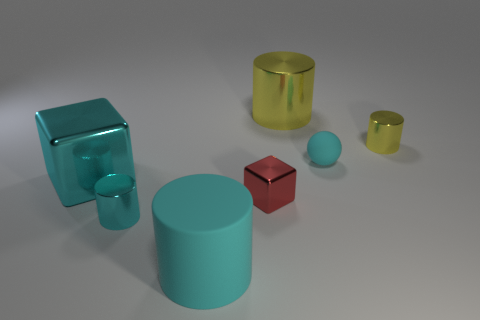Add 3 small shiny things. How many objects exist? 10 Subtract all blocks. How many objects are left? 5 Add 6 big cylinders. How many big cylinders are left? 8 Add 6 large purple metallic cylinders. How many large purple metallic cylinders exist? 6 Subtract 0 green spheres. How many objects are left? 7 Subtract all small green matte objects. Subtract all large shiny objects. How many objects are left? 5 